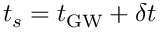<formula> <loc_0><loc_0><loc_500><loc_500>t _ { s } = t _ { G W } + \delta t</formula> 